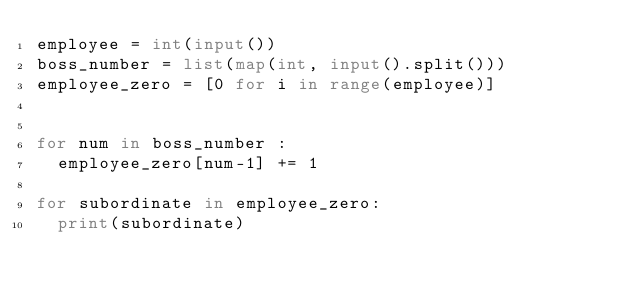Convert code to text. <code><loc_0><loc_0><loc_500><loc_500><_Python_>employee = int(input())
boss_number = list(map(int, input().split()))
employee_zero = [0 for i in range(employee)]


for num in boss_number :
  employee_zero[num-1] += 1

for subordinate in employee_zero:
  print(subordinate)</code> 